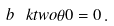Convert formula to latex. <formula><loc_0><loc_0><loc_500><loc_500>b \, \ k t w o { \theta } { 0 } = 0 \, .</formula> 